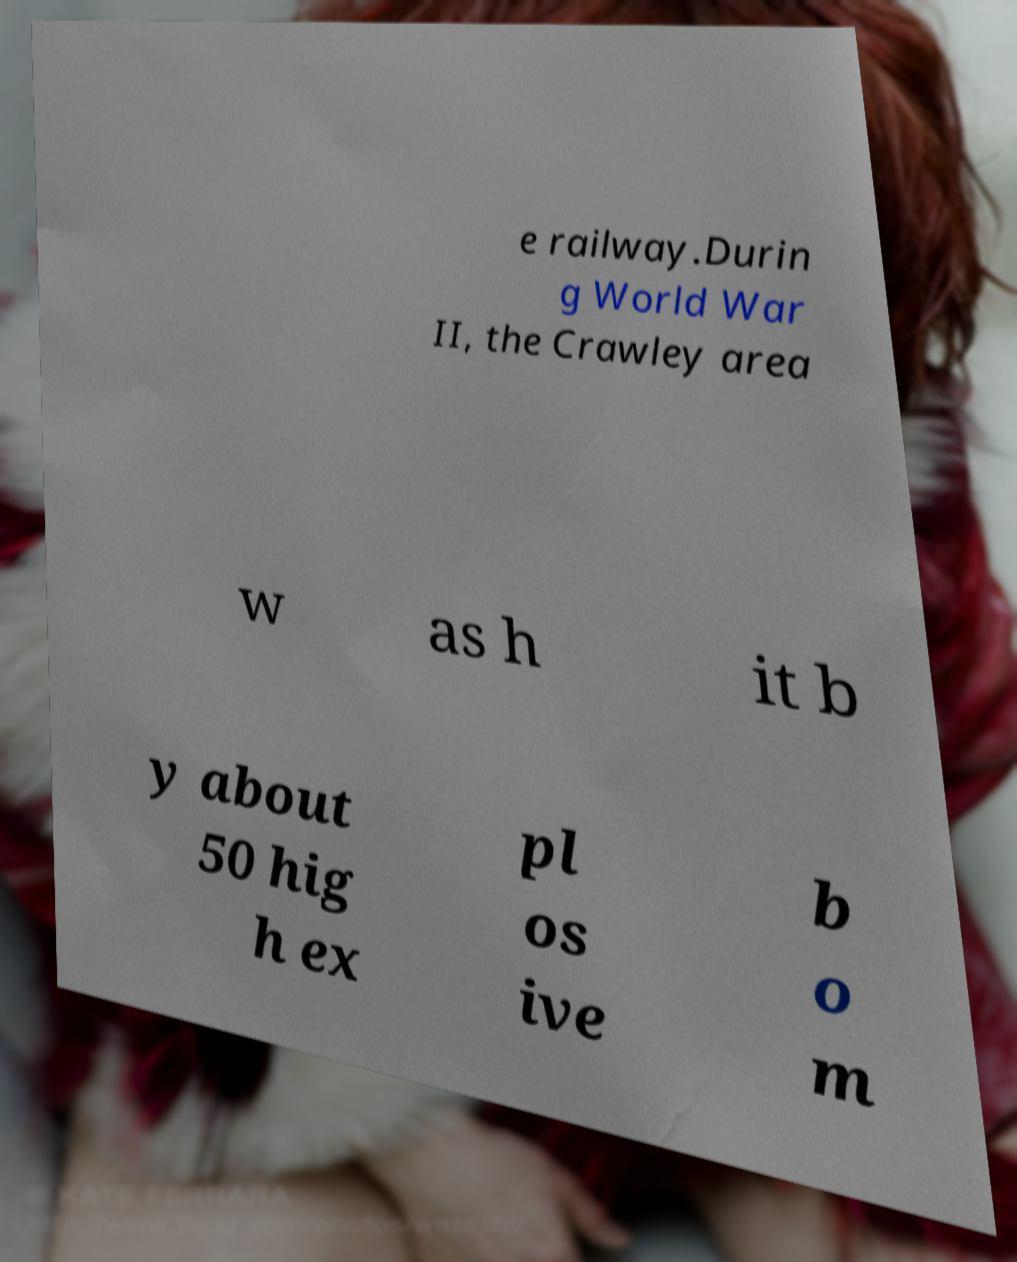I need the written content from this picture converted into text. Can you do that? e railway.Durin g World War II, the Crawley area w as h it b y about 50 hig h ex pl os ive b o m 